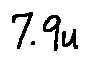Convert formula to latex. <formula><loc_0><loc_0><loc_500><loc_500>7 . 9 u</formula> 